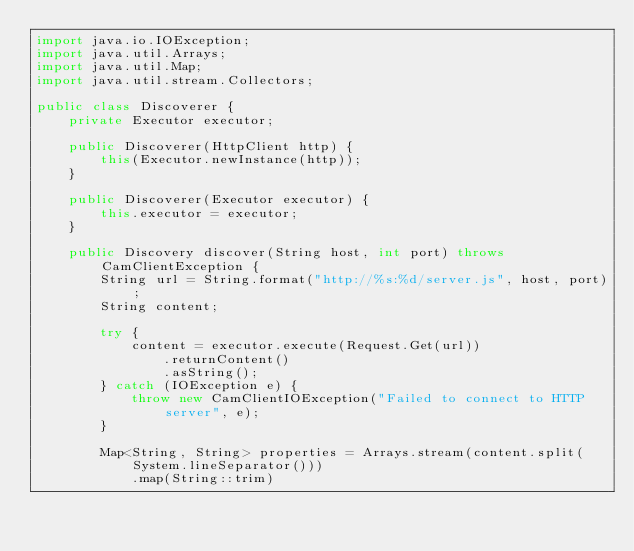Convert code to text. <code><loc_0><loc_0><loc_500><loc_500><_Java_>import java.io.IOException;
import java.util.Arrays;
import java.util.Map;
import java.util.stream.Collectors;

public class Discoverer {
    private Executor executor;

    public Discoverer(HttpClient http) {
        this(Executor.newInstance(http));
    }

    public Discoverer(Executor executor) {
        this.executor = executor;
    }

    public Discovery discover(String host, int port) throws CamClientException {
        String url = String.format("http://%s:%d/server.js", host, port);
        String content;

        try {
            content = executor.execute(Request.Get(url))
                .returnContent()
                .asString();
        } catch (IOException e) {
            throw new CamClientIOException("Failed to connect to HTTP server", e);
        }

        Map<String, String> properties = Arrays.stream(content.split(System.lineSeparator()))
            .map(String::trim)</code> 